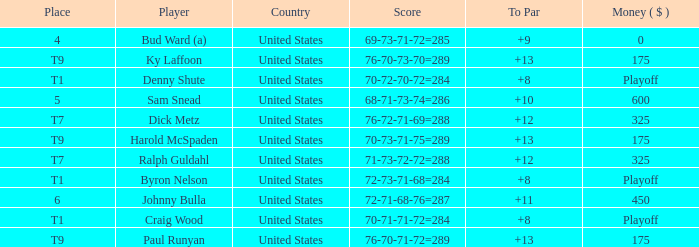What was the country for Sam Snead? United States. Could you help me parse every detail presented in this table? {'header': ['Place', 'Player', 'Country', 'Score', 'To Par', 'Money ( $ )'], 'rows': [['4', 'Bud Ward (a)', 'United States', '69-73-71-72=285', '+9', '0'], ['T9', 'Ky Laffoon', 'United States', '76-70-73-70=289', '+13', '175'], ['T1', 'Denny Shute', 'United States', '70-72-70-72=284', '+8', 'Playoff'], ['5', 'Sam Snead', 'United States', '68-71-73-74=286', '+10', '600'], ['T7', 'Dick Metz', 'United States', '76-72-71-69=288', '+12', '325'], ['T9', 'Harold McSpaden', 'United States', '70-73-71-75=289', '+13', '175'], ['T7', 'Ralph Guldahl', 'United States', '71-73-72-72=288', '+12', '325'], ['T1', 'Byron Nelson', 'United States', '72-73-71-68=284', '+8', 'Playoff'], ['6', 'Johnny Bulla', 'United States', '72-71-68-76=287', '+11', '450'], ['T1', 'Craig Wood', 'United States', '70-71-71-72=284', '+8', 'Playoff'], ['T9', 'Paul Runyan', 'United States', '76-70-71-72=289', '+13', '175']]} 